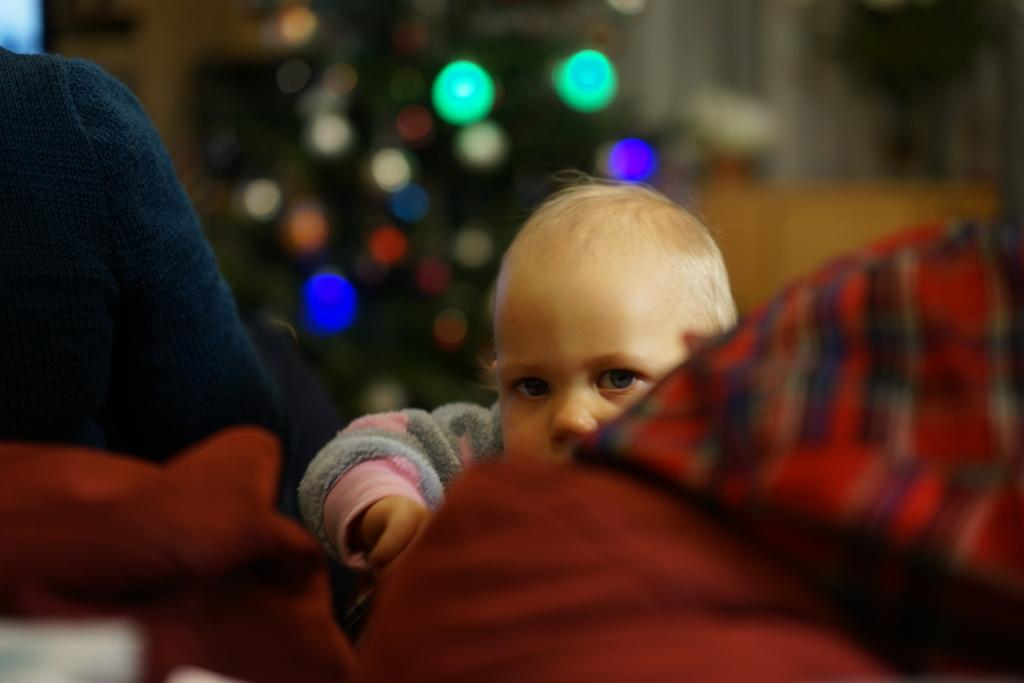What is the main subject of the image? The main subject of the image is a kid. What else can be seen in the image besides the kid? There are clothes visible in the image. Can you describe the background of the image? The background of the image is blurry. What type of hope can be seen being offered to the industry in the image? There is no reference to hope, offering, or industry in the image; it features a kid and clothes. 